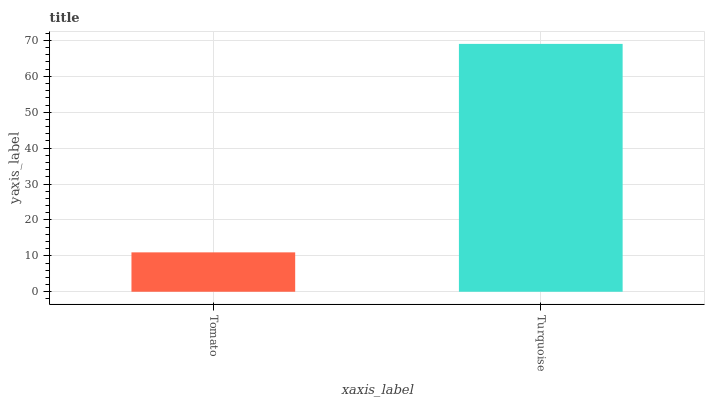Is Tomato the minimum?
Answer yes or no. Yes. Is Turquoise the maximum?
Answer yes or no. Yes. Is Turquoise the minimum?
Answer yes or no. No. Is Turquoise greater than Tomato?
Answer yes or no. Yes. Is Tomato less than Turquoise?
Answer yes or no. Yes. Is Tomato greater than Turquoise?
Answer yes or no. No. Is Turquoise less than Tomato?
Answer yes or no. No. Is Turquoise the high median?
Answer yes or no. Yes. Is Tomato the low median?
Answer yes or no. Yes. Is Tomato the high median?
Answer yes or no. No. Is Turquoise the low median?
Answer yes or no. No. 